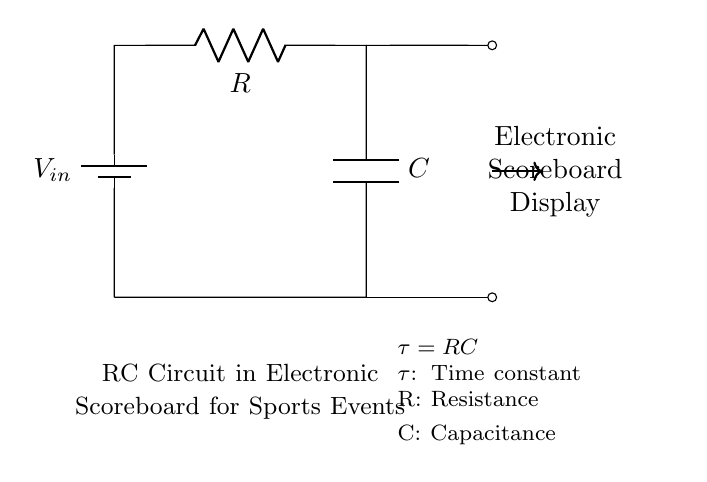What is the type of circuit shown? The circuit is an RC (Resistor-Capacitor) circuit, which is indicated by the presence of both a resistor and a capacitor connected in series.
Answer: RC circuit What components are present in the circuit? The circuit consists of a battery, a resistor, and a capacitor. The battery provides the input voltage, while the resistor and capacitor are components connected in series.
Answer: Battery, resistor, capacitor What is the symbol used for the capacitor? The capacitor is represented by a two parallel lines symbol in the diagram, which denotes its ability to store electrical energy.
Answer: Two parallel lines What does the letter "R" represent in this circuit? "R" stands for resistance, which describes the opposition to the flow of current in the circuit. This is labeled on the diagram next to the resistor.
Answer: Resistance What does the time constant (tau) represent in this circuit? The time constant (tau) is the product of resistance and capacitance (tau = RC), and it represents the time it takes for the voltage across the capacitor to charge to approximately 63.2% of the input voltage when charged through the resistor.
Answer: Time to charge What happens to the voltage across the capacitor over time when the switch is closed? The voltage across the capacitor increases exponentially until it reaches the input voltage, following the time constant defined by the resistor and capacitor values, because of the RC time constant behavior.
Answer: Increases exponentially How can the time constant be calculated in this circuit? The time constant is calculated using the formula tau = R multiplied by C, where R is the resistance in ohms and C is the capacitance in farads. This calculation gives the time constant in seconds, reflecting the charging and discharging behavior of the capacitor.
Answer: Product of R and C 